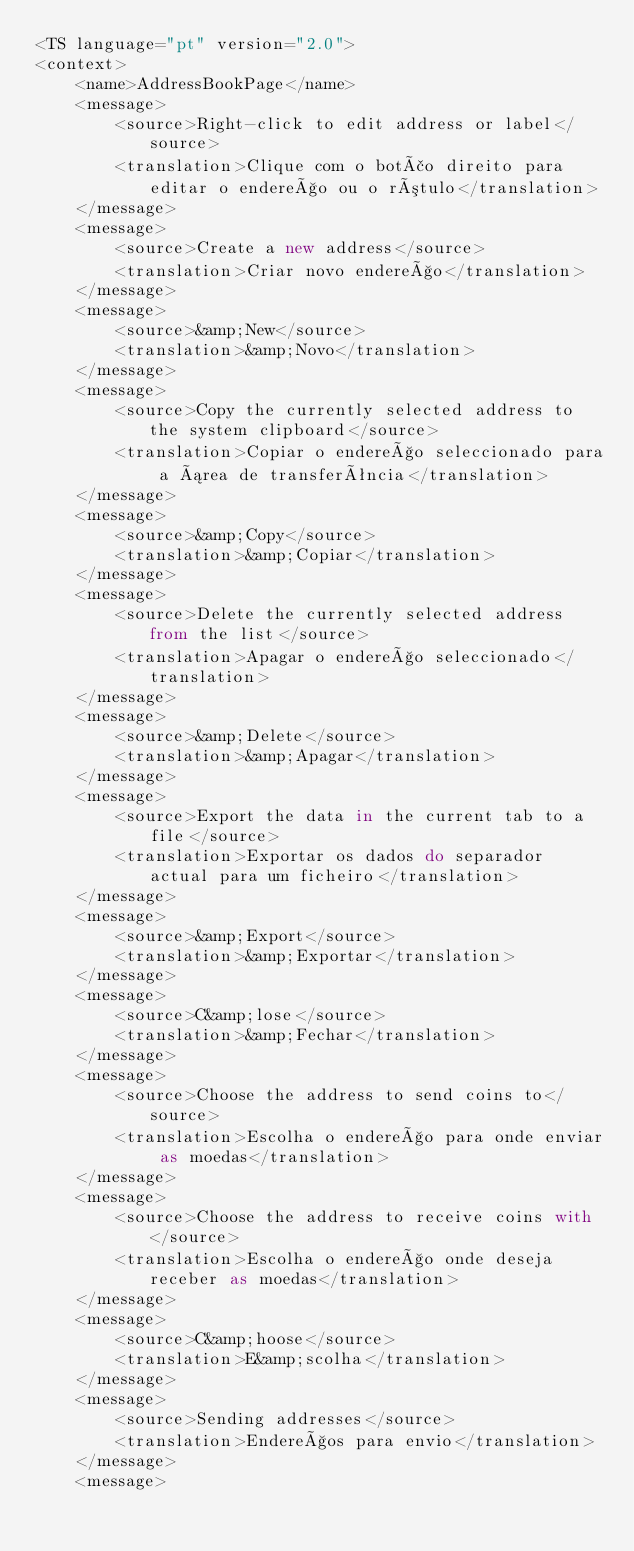Convert code to text. <code><loc_0><loc_0><loc_500><loc_500><_TypeScript_><TS language="pt" version="2.0">
<context>
    <name>AddressBookPage</name>
    <message>
        <source>Right-click to edit address or label</source>
        <translation>Clique com o botão direito para editar o endereço ou o rótulo</translation>
    </message>
    <message>
        <source>Create a new address</source>
        <translation>Criar novo endereço</translation>
    </message>
    <message>
        <source>&amp;New</source>
        <translation>&amp;Novo</translation>
    </message>
    <message>
        <source>Copy the currently selected address to the system clipboard</source>
        <translation>Copiar o endereço seleccionado para a área de transferência</translation>
    </message>
    <message>
        <source>&amp;Copy</source>
        <translation>&amp;Copiar</translation>
    </message>
    <message>
        <source>Delete the currently selected address from the list</source>
        <translation>Apagar o endereço seleccionado</translation>
    </message>
    <message>
        <source>&amp;Delete</source>
        <translation>&amp;Apagar</translation>
    </message>
    <message>
        <source>Export the data in the current tab to a file</source>
        <translation>Exportar os dados do separador actual para um ficheiro</translation>
    </message>
    <message>
        <source>&amp;Export</source>
        <translation>&amp;Exportar</translation>
    </message>
    <message>
        <source>C&amp;lose</source>
        <translation>&amp;Fechar</translation>
    </message>
    <message>
        <source>Choose the address to send coins to</source>
        <translation>Escolha o endereço para onde enviar as moedas</translation>
    </message>
    <message>
        <source>Choose the address to receive coins with</source>
        <translation>Escolha o endereço onde deseja receber as moedas</translation>
    </message>
    <message>
        <source>C&amp;hoose</source>
        <translation>E&amp;scolha</translation>
    </message>
    <message>
        <source>Sending addresses</source>
        <translation>Endereços para envio</translation>
    </message>
    <message></code> 